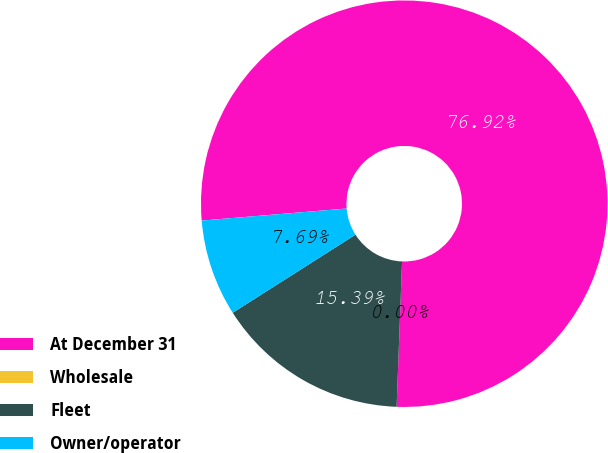Convert chart. <chart><loc_0><loc_0><loc_500><loc_500><pie_chart><fcel>At December 31<fcel>Wholesale<fcel>Fleet<fcel>Owner/operator<nl><fcel>76.92%<fcel>0.0%<fcel>15.39%<fcel>7.69%<nl></chart> 